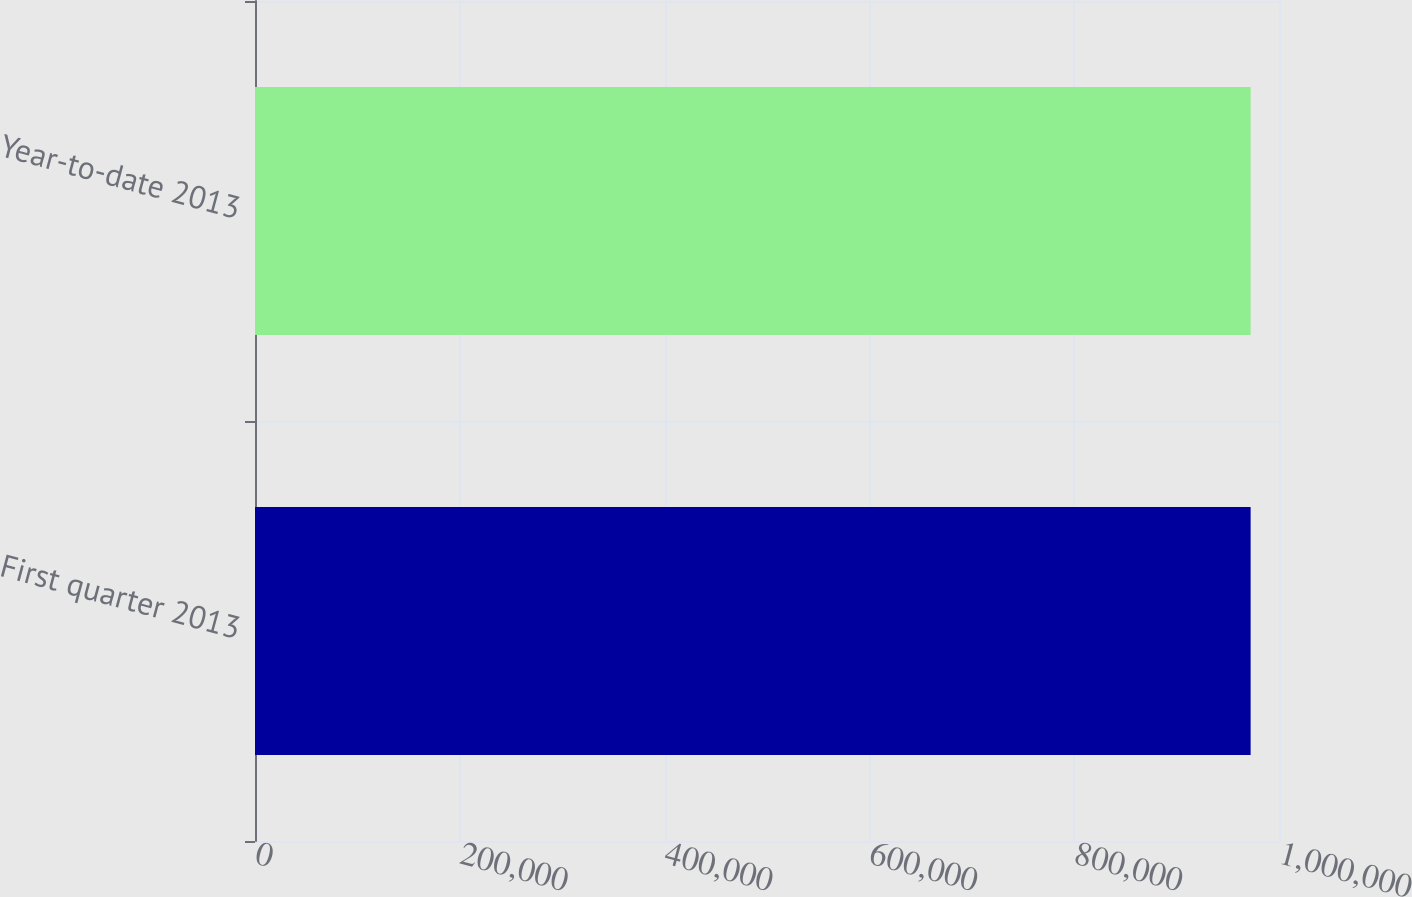<chart> <loc_0><loc_0><loc_500><loc_500><bar_chart><fcel>First quarter 2013<fcel>Year-to-date 2013<nl><fcel>972292<fcel>972292<nl></chart> 